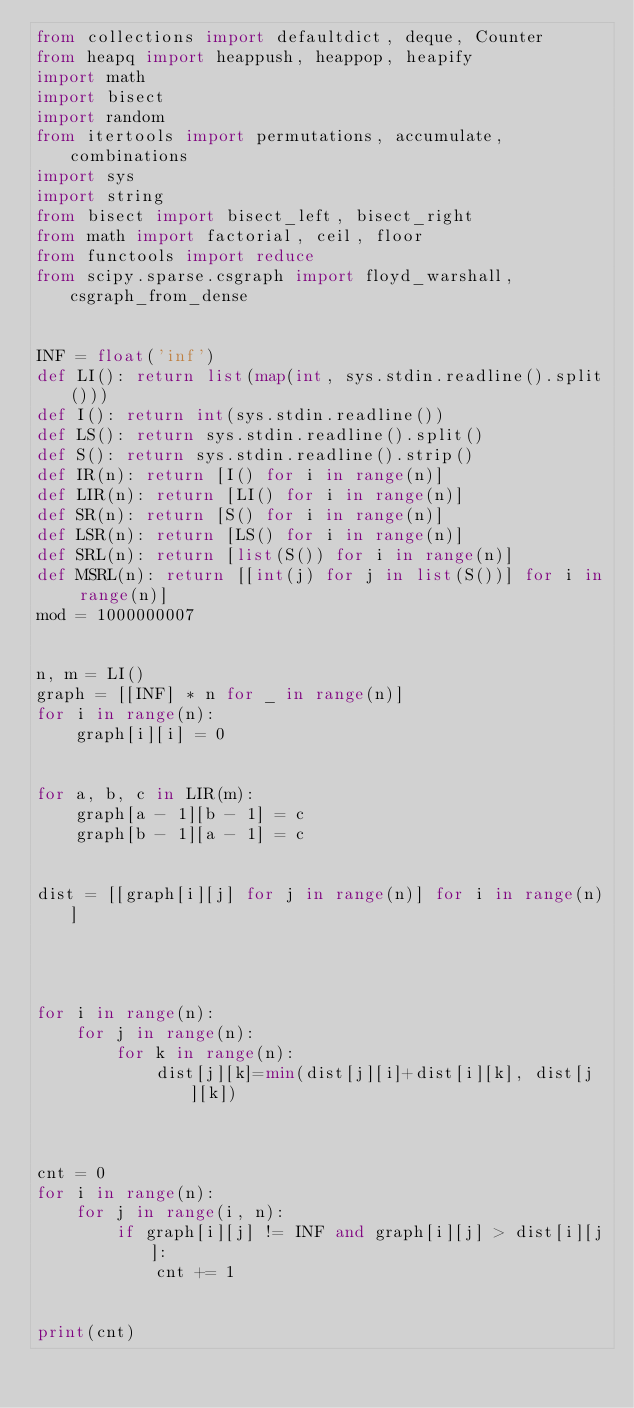Convert code to text. <code><loc_0><loc_0><loc_500><loc_500><_Python_>from collections import defaultdict, deque, Counter
from heapq import heappush, heappop, heapify
import math
import bisect
import random
from itertools import permutations, accumulate, combinations
import sys
import string
from bisect import bisect_left, bisect_right
from math import factorial, ceil, floor
from functools import reduce
from scipy.sparse.csgraph import floyd_warshall, csgraph_from_dense


INF = float('inf')
def LI(): return list(map(int, sys.stdin.readline().split()))
def I(): return int(sys.stdin.readline())
def LS(): return sys.stdin.readline().split()
def S(): return sys.stdin.readline().strip()
def IR(n): return [I() for i in range(n)]
def LIR(n): return [LI() for i in range(n)]
def SR(n): return [S() for i in range(n)]
def LSR(n): return [LS() for i in range(n)]
def SRL(n): return [list(S()) for i in range(n)]
def MSRL(n): return [[int(j) for j in list(S())] for i in range(n)]
mod = 1000000007


n, m = LI()
graph = [[INF] * n for _ in range(n)]
for i in range(n):
    graph[i][i] = 0


for a, b, c in LIR(m):
    graph[a - 1][b - 1] = c
    graph[b - 1][a - 1] = c


dist = [[graph[i][j] for j in range(n)] for i in range(n)]




for i in range(n):
    for j in range(n):
        for k in range(n):
            dist[j][k]=min(dist[j][i]+dist[i][k], dist[j][k])



cnt = 0
for i in range(n):
    for j in range(i, n):
        if graph[i][j] != INF and graph[i][j] > dist[i][j]:
            cnt += 1


print(cnt)</code> 